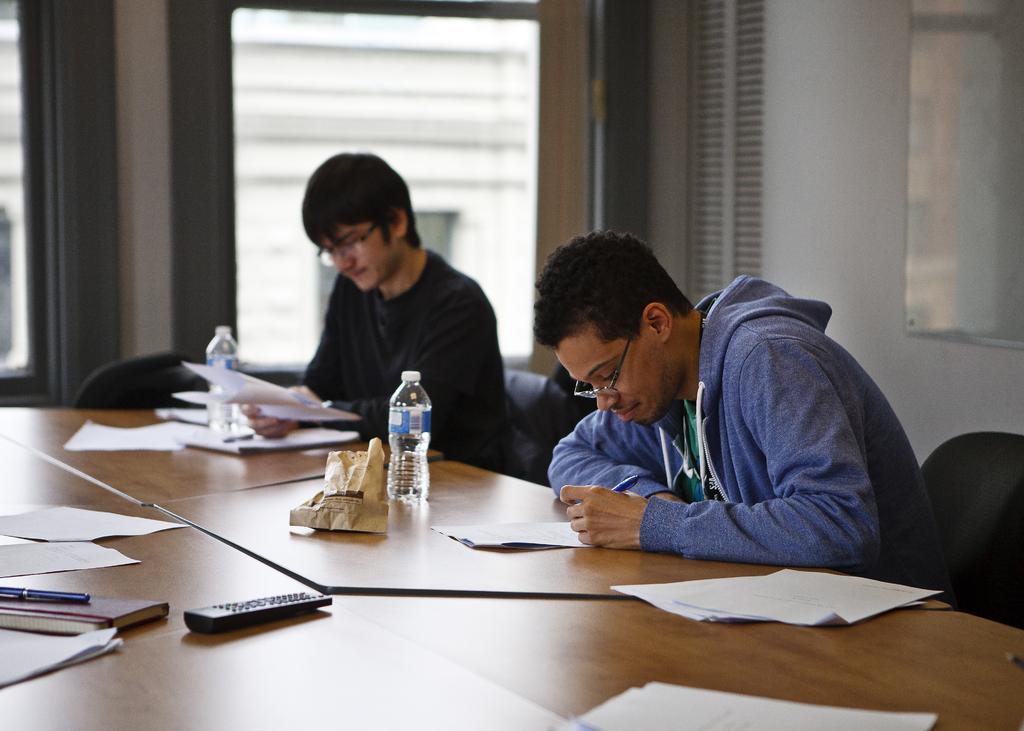In one or two sentences, can you explain what this image depicts? In the center of the image there is a table. On the table we can see papers, book, pen remote, bottles, packet. Beside the table two persons are sitting and holding paper, pen in their hand. In the background of the image we can see wall, windows, mirror. In the middle of the image we can see some chairs. 